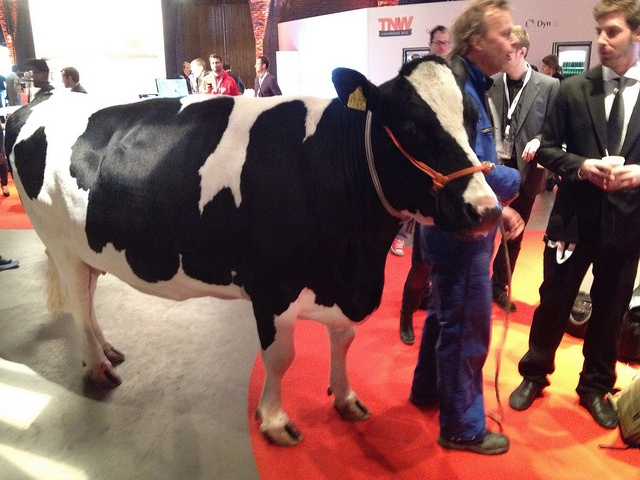Describe the objects in this image and their specific colors. I can see cow in salmon, black, gray, ivory, and brown tones, people in salmon, black, gray, brown, and maroon tones, people in salmon, black, maroon, navy, and brown tones, people in salmon, black, gray, maroon, and brown tones, and tv in salmon, white, darkgray, gray, and teal tones in this image. 